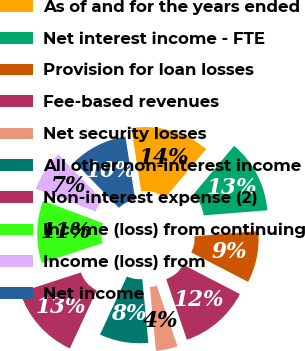Convert chart. <chart><loc_0><loc_0><loc_500><loc_500><pie_chart><fcel>As of and for the years ended<fcel>Net interest income - FTE<fcel>Provision for loan losses<fcel>Fee-based revenues<fcel>Net security losses<fcel>All other non-interest income<fcel>Non-interest expense (2)<fcel>Income (loss) from continuing<fcel>Income (loss) from<fcel>Net income<nl><fcel>13.55%<fcel>12.62%<fcel>8.88%<fcel>12.15%<fcel>3.74%<fcel>8.41%<fcel>13.08%<fcel>10.75%<fcel>7.01%<fcel>9.81%<nl></chart> 